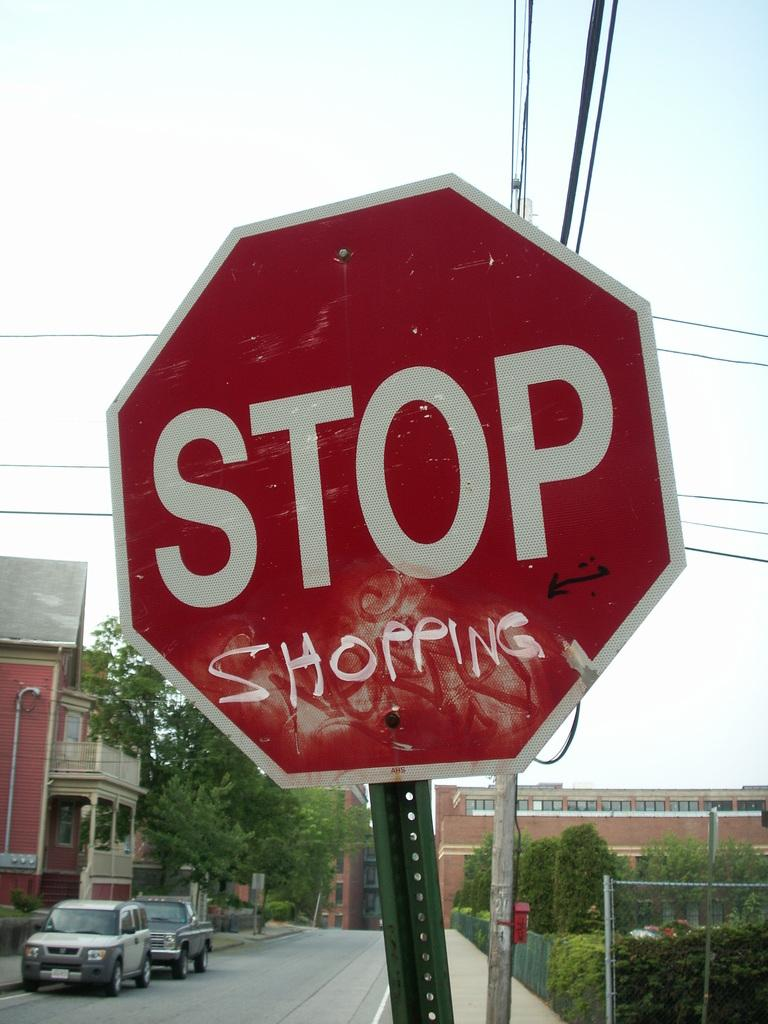<image>
Present a compact description of the photo's key features. A STOP sign is shown with someone writing the word shopping underneath it. 